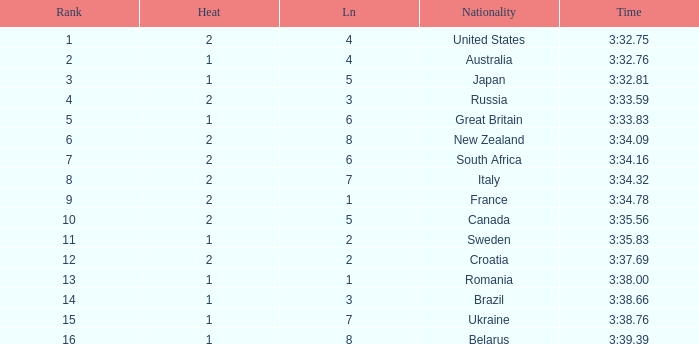Can you tell me the Time that has the Heat of 1, and the Lane of 2? 3:35.83. 